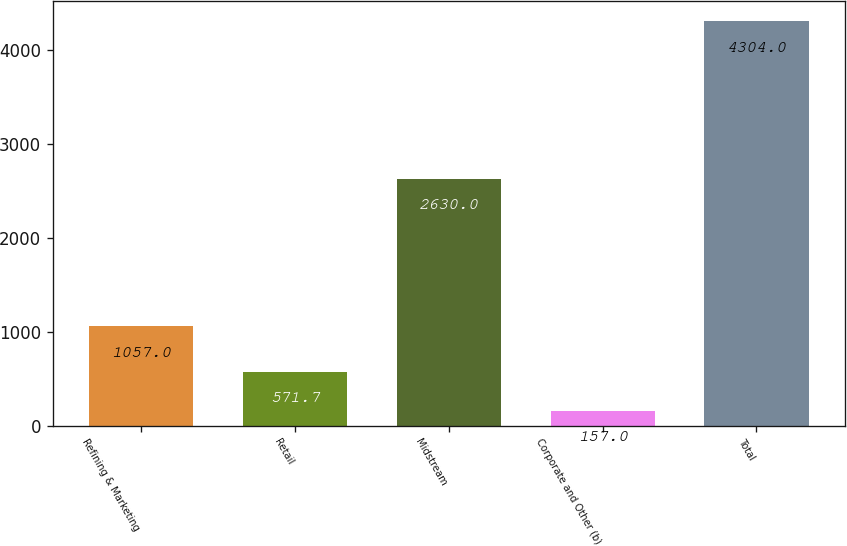Convert chart. <chart><loc_0><loc_0><loc_500><loc_500><bar_chart><fcel>Refining & Marketing<fcel>Retail<fcel>Midstream<fcel>Corporate and Other (b)<fcel>Total<nl><fcel>1057<fcel>571.7<fcel>2630<fcel>157<fcel>4304<nl></chart> 